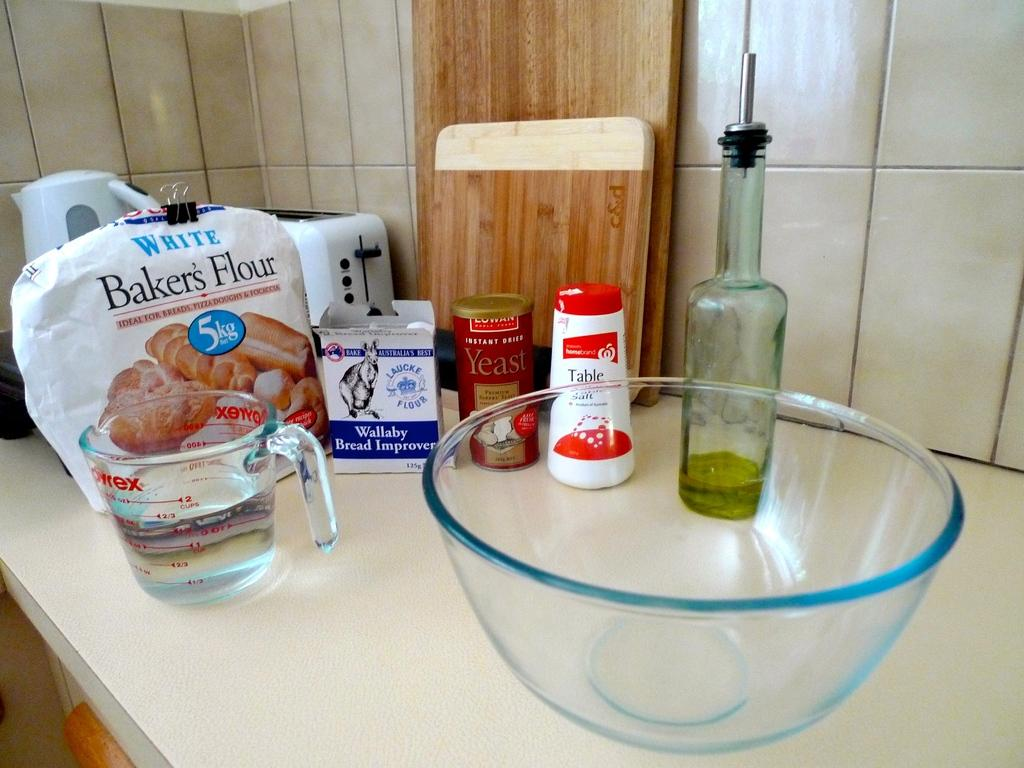<image>
Give a short and clear explanation of the subsequent image. A bowl on a counter top with several ingredients including bakers flour and salt. 